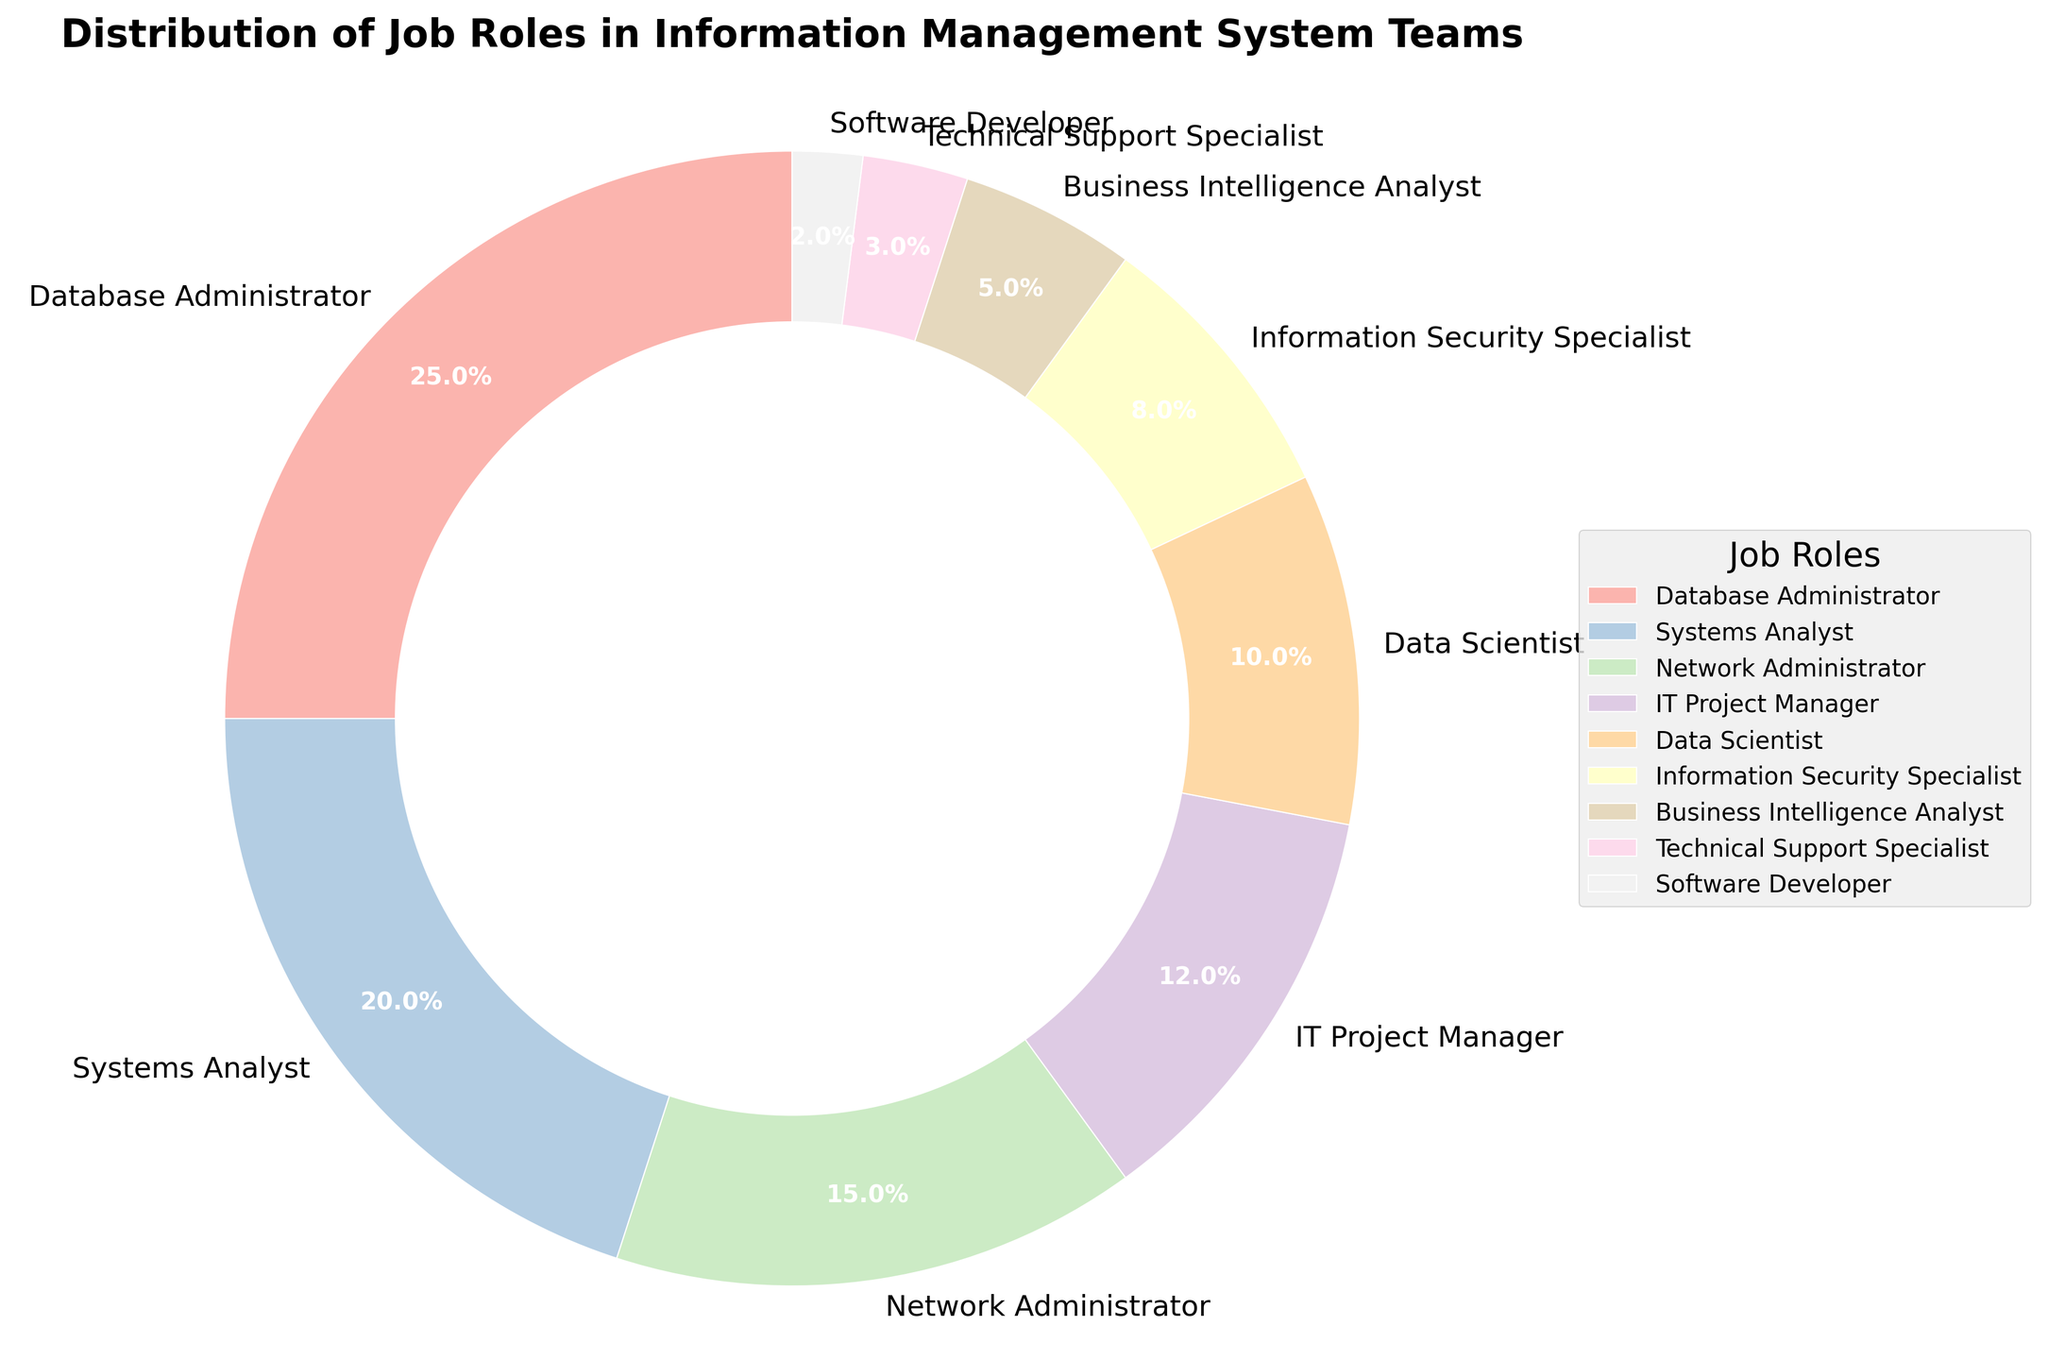Which role constitutes the largest proportion in the Information Management System teams? Look at the segment with the largest percentage. The Database Administrator role has the largest portion, which is 25%.
Answer: Database Administrator What is the combined percentage of Database Administrators and Systems Analysts? Add the percentages of Database Administrators and Systems Analysts together. These values are 25% and 20%, respectively. So, 25% + 20% = 45%.
Answer: 45% How many roles have a percentage less than or equal to 10%? Identify and count the roles whose segments represent 10% or less. These roles are Data Scientist (10%), Information Security Specialist (8%), Business Intelligence Analyst (5%), Technical Support Specialist (3%), and Software Developer (2%), totaling 5 roles.
Answer: 5 roles Which job role has the smallest proportion in the chart? Locate the segment with the smallest percentage. The Software Developer role has the smallest proportion, which is 2%.
Answer: Software Developer Are there more Database Administrators or IT Project Managers in the teams? Compare the percentages of Database Administrators and IT Project Managers. The Database Administrator role is 25%, and the IT Project Manager role is 12%. Since 25% is greater than 12%, there are more Database Administrators.
Answer: Database Administrators Which roles combined make up less than a quarter of the team? Sum the percentages of roles until the total is less than 25%. Roles and their percentages are: Business Intelligence Analyst (5%), Technical Support Specialist (3%), and Software Developer (2%). 5% + 3% + 2% = 10%, which is less than 25%.
Answer: Business Intelligence Analyst, Technical Support Specialist, Software Developer What is the percentage difference between Network Administrators and Data Scientists? Subtract the percentage of Data Scientists from Network Administrators. Network Administrators are 15%, and Data Scientists are 10%. The difference is 15% - 10% = 5%.
Answer: 5% Which role has a larger portion, Information Security Specialist or Business Intelligence Analyst? Compare the percentages of Information Security Specialist and Business Intelligence Analyst. The Information Security Specialist has 8%, while Business Intelligence Analyst has 5%. Since 8% is greater than 5%, Information Security Specialist has a larger portion.
Answer: Information Security Specialist What is the average percentage of the three roles with the largest portions? Identify the three roles with the largest percentages: Database Administrator (25%), Systems Analyst (20%), and Network Administrator (15%). Calculate the average by summing these percentages and dividing by 3: (25% + 20% + 15%) / 3 = 60% / 3 = 20%.
Answer: 20% How visually distinguishable is the role with the smallest percentage compared to the role with the largest percentage? Compare the visual size differences using the pie chart’s segments. The Database Administrator segment is quite large, while the Software Developer segment is very small.
Answer: The differences are very noticeable 